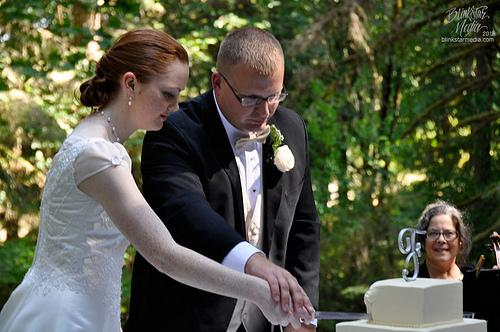Identify the action taking place in the image involving the newly married couple. The newly married couple is cutting a wedding cake together. Provide a brief caption for the image. Bride and groom celebrating their wedding by cutting a square layer cake. Based on the details provided, is the event happening indoors or outdoors? The event is happening outdoors. What kind of facial feature of the man has freckles? The man's arm has freckles. What kind of clothing is the woman in the image wearing? The woman is wearing a wedding dress. Mention the type of accessory the woman is wearing on her ears. The woman is wearing pearl earrings. In the image, what type of event are the man and the woman participating in? The man and the woman are participating in a wedding event. In this image, how many people are wearing glasses? Two people are wearing glasses. Find and describe one small detail on the man's attire in the image. The man is wearing a tan bowtie. List all the facial features of the man that have a image. Head, eyes, nose, ear, and mouth. On the right side of the image, there's a child wearing a red shirt and blowing bubbles; look at that adorable moment. There is no mention of a child, a red shirt, or blowing bubbles in the image captions. The instruction creates a false scene within the image, which may mislead the user. What is the shape of the wedding cake in the image? square layers Could you please find the dog sitting next to the couple in the image? There is no mention of a dog in the image captions. The request to find a non-existent dog in the image may cause confusion for the user. Notice how the groom is carrying an umbrella to shield the couple from the rain. An umbrella and rain are not mentioned in the image captions. The instruction fabricates this detail, potentially confusing users who try to find the umbrella. Identify the event taking place in the image. wedding In the photo, please pay attention to the beautiful bouquet the bride is holding. No information about the bride holding a bouquet is provided in the image captions. The instruction falsely claims the bride is holding a bouquet, which could mislead the user. Describe the appearance of the man in the image. wearing glasses, black jacket, white shirt, and tan bowtie Please provide a styled caption for the image. Love blooms as the newlyweds slice into a cake adorned with a silver initial topper, surrounded by a breathtaking outdoor scene. Which one is true about the woman in the image? (a) smiling middle aged woman (b) young happy bride (c) senior lady wearing a hat (a) smiling middle aged woman The background features a stunning sunset over a mountain range, making the image even more romantic. The image captions do not include any information about a sunset or mountain range. The instruction falsely adds a background detail, which could lead to confusion. 